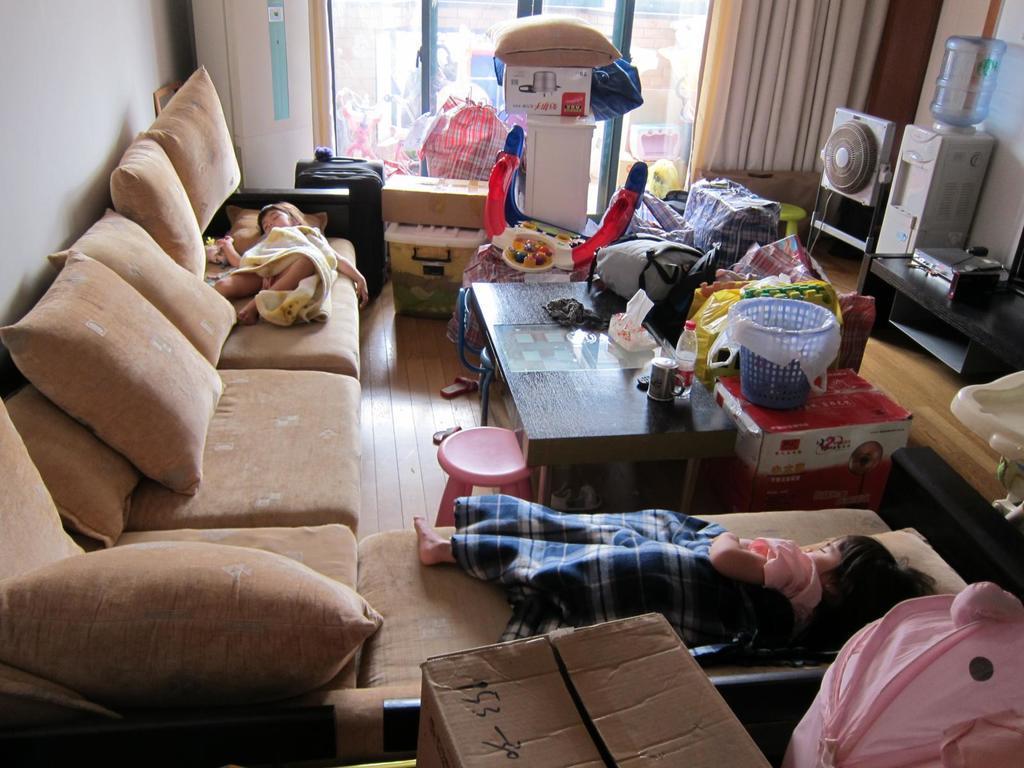How would you summarize this image in a sentence or two? In this picture we can see two kids who are sleeping on the sofa. These are the pillows. And this is floor. Here we can see a table. On the table there is a basket and bags. On the background there is a glass and this is curtain. Here we can see some electronic devices. And these are the boxes. 